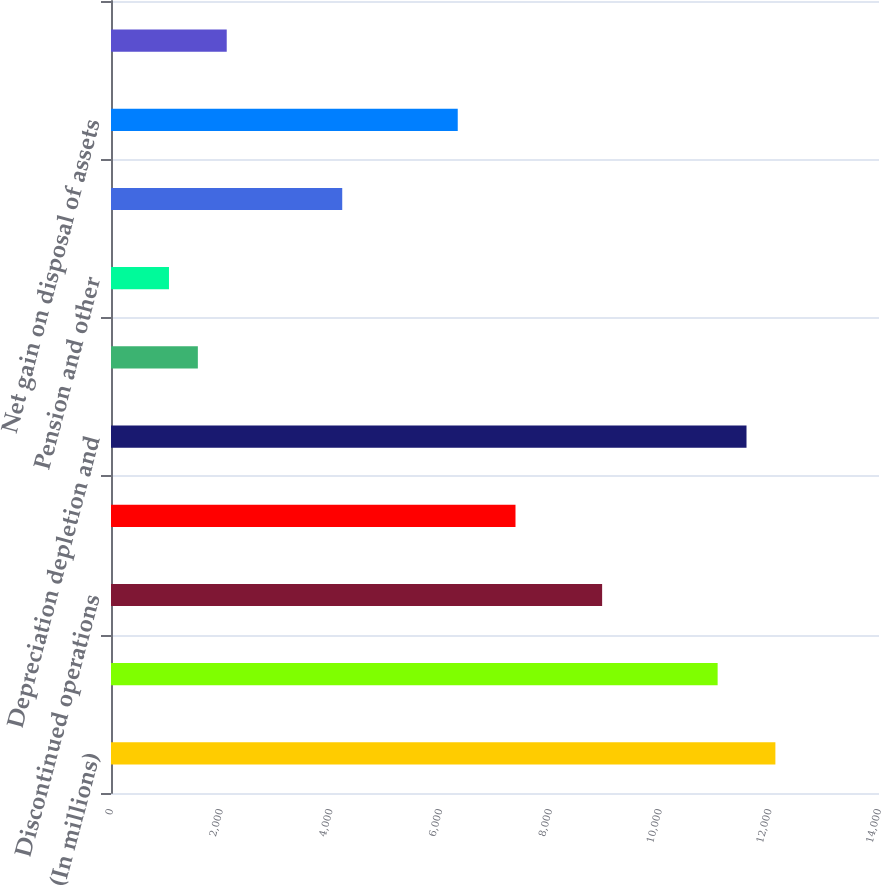<chart> <loc_0><loc_0><loc_500><loc_500><bar_chart><fcel>(In millions)<fcel>Net income<fcel>Discontinued operations<fcel>Deferred income taxes<fcel>Depreciation depletion and<fcel>Impairments<fcel>Pension and other<fcel>Exploratory dry well costs and<fcel>Net gain on disposal of assets<fcel>Equity method investments net<nl><fcel>12111.2<fcel>11058.4<fcel>8952.8<fcel>7373.6<fcel>11584.8<fcel>1583.2<fcel>1056.8<fcel>4215.2<fcel>6320.8<fcel>2109.6<nl></chart> 